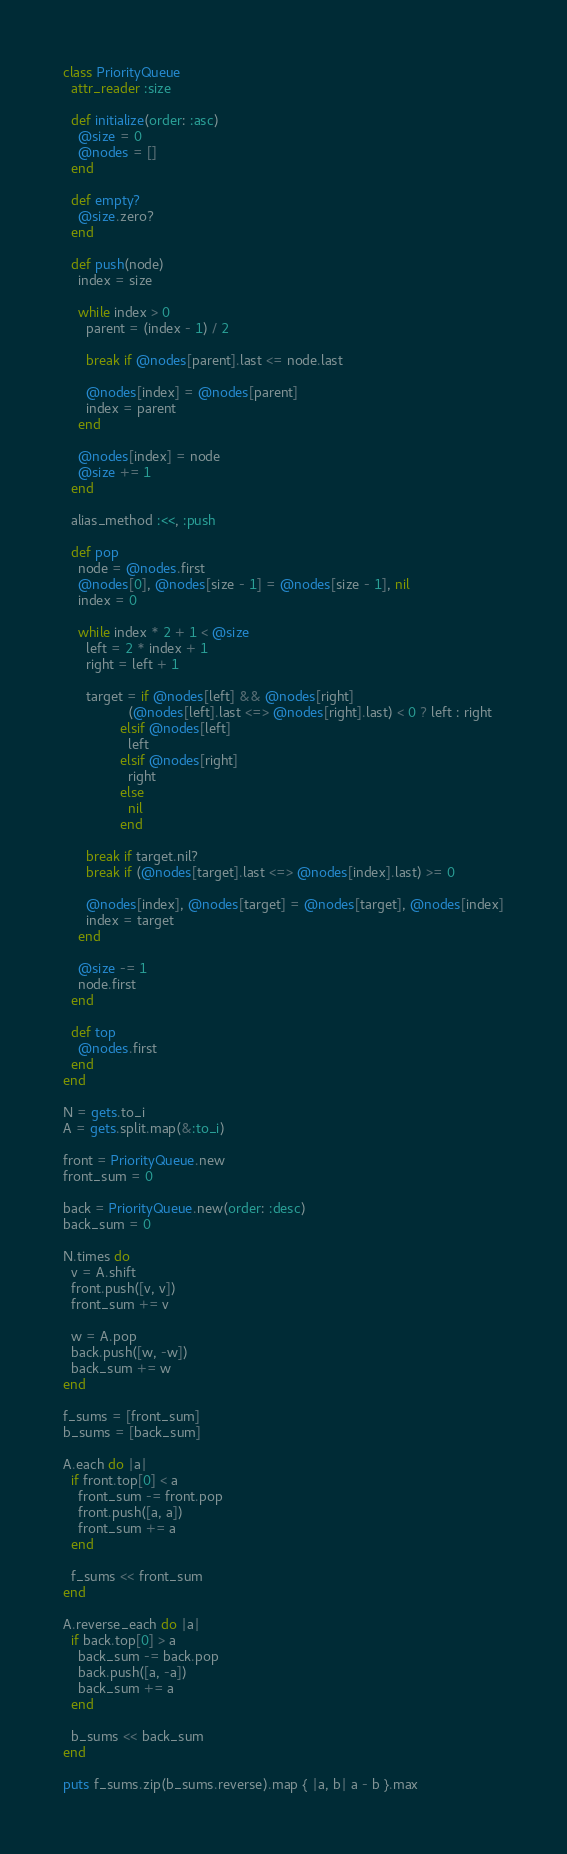Convert code to text. <code><loc_0><loc_0><loc_500><loc_500><_Ruby_>class PriorityQueue
  attr_reader :size

  def initialize(order: :asc)
    @size = 0
    @nodes = []
  end

  def empty?
    @size.zero?
  end

  def push(node)
    index = size

    while index > 0
      parent = (index - 1) / 2

      break if @nodes[parent].last <= node.last

      @nodes[index] = @nodes[parent]
      index = parent
    end

    @nodes[index] = node
    @size += 1
  end

  alias_method :<<, :push

  def pop
    node = @nodes.first
    @nodes[0], @nodes[size - 1] = @nodes[size - 1], nil
    index = 0

    while index * 2 + 1 < @size
      left = 2 * index + 1
      right = left + 1

      target = if @nodes[left] && @nodes[right]
                 (@nodes[left].last <=> @nodes[right].last) < 0 ? left : right
               elsif @nodes[left]
                 left
               elsif @nodes[right]
                 right
               else
                 nil
               end

      break if target.nil?
      break if (@nodes[target].last <=> @nodes[index].last) >= 0

      @nodes[index], @nodes[target] = @nodes[target], @nodes[index]
      index = target
    end

    @size -= 1
    node.first
  end

  def top
    @nodes.first
  end
end

N = gets.to_i
A = gets.split.map(&:to_i)

front = PriorityQueue.new
front_sum = 0

back = PriorityQueue.new(order: :desc)
back_sum = 0

N.times do
  v = A.shift
  front.push([v, v])
  front_sum += v

  w = A.pop
  back.push([w, -w])
  back_sum += w
end

f_sums = [front_sum]
b_sums = [back_sum]

A.each do |a|
  if front.top[0] < a
    front_sum -= front.pop
    front.push([a, a])
    front_sum += a
  end

  f_sums << front_sum
end

A.reverse_each do |a|
  if back.top[0] > a
    back_sum -= back.pop
    back.push([a, -a])
    back_sum += a
  end

  b_sums << back_sum
end

puts f_sums.zip(b_sums.reverse).map { |a, b| a - b }.max

</code> 